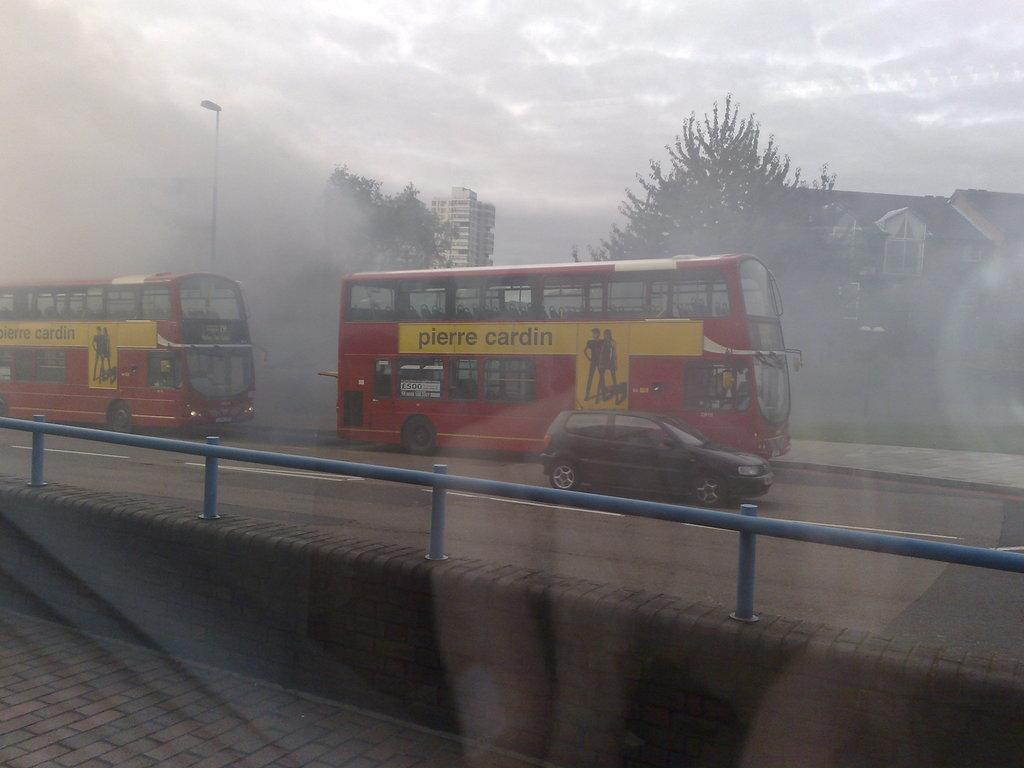<image>
Create a compact narrative representing the image presented. Two red buses from the company Pierre Cardin. 